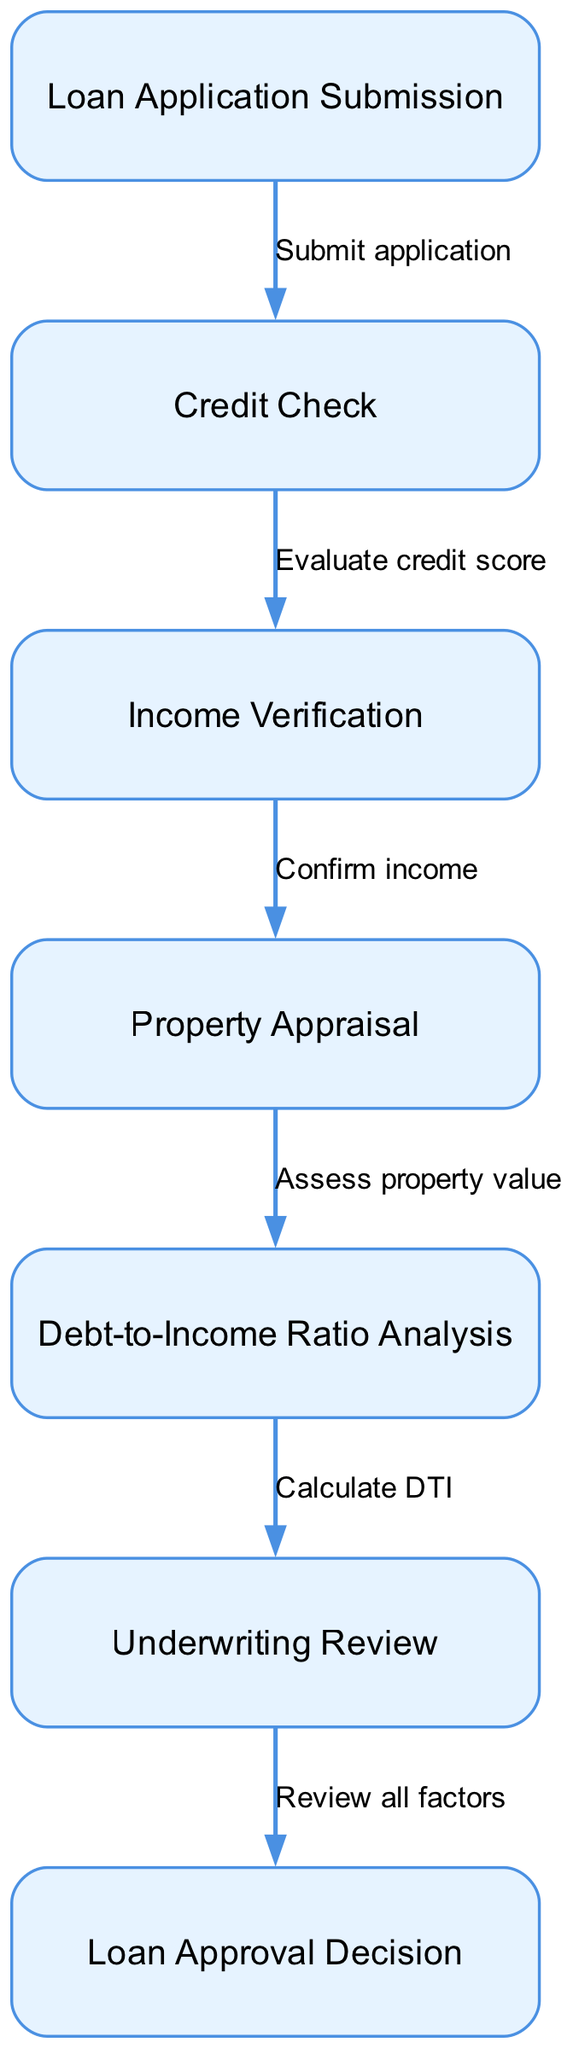What is the first step in the mortgage approval process? The first step in the process is "Loan Application Submission," which is depicted as the initial node in the diagram.
Answer: Loan Application Submission How many steps are there in the process? The diagram contains a total of seven distinct steps, as represented by the seven nodes within the flow.
Answer: Seven What happens after the Credit Check? After the Credit Check, the next step is "Income Verification," indicated by the edge leading from node 2 to node 3.
Answer: Income Verification Which step evaluates the property value? The "Property Appraisal" step is where the property value is assessed, represented as node 4 in the diagram.
Answer: Property Appraisal What is assessed after "Income Verification"? After "Income Verification," the following assessment is "Property Appraisal," as shown by the flow from node 3 to node 4.
Answer: Property Appraisal How many edges are there connecting the nodes? The diagram has a total of six edges connecting the various nodes, representing the relationships between the steps in the approval process.
Answer: Six What step comes before the loan approval decision? The step that precedes the loan approval decision is "Underwriting Review," which is indicated as node 6 right before node 7.
Answer: Underwriting Review What is calculated during the Debt-to-Income Ratio Analysis? During the Debt-to-Income Ratio Analysis, the "DTI" is calculated, which is indicated by the flow after the "Property Appraisal" step.
Answer: DTI What factor is reviewed before making a loan approval decision? Before making a loan approval decision, the factor that is reviewed is "all factors," as stated in the connection leading to the last node in the flow.
Answer: All factors 